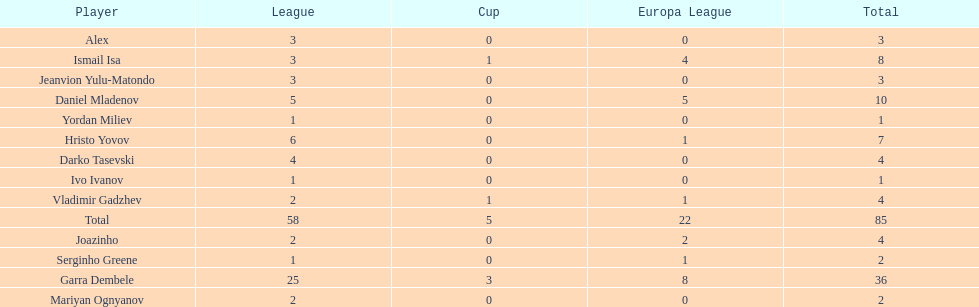Write the full table. {'header': ['Player', 'League', 'Cup', 'Europa League', 'Total'], 'rows': [['Alex', '3', '0', '0', '3'], ['Ismail Isa', '3', '1', '4', '8'], ['Jeanvion Yulu-Matondo', '3', '0', '0', '3'], ['Daniel Mladenov', '5', '0', '5', '10'], ['Yordan Miliev', '1', '0', '0', '1'], ['Hristo Yovov', '6', '0', '1', '7'], ['Darko Tasevski', '4', '0', '0', '4'], ['Ivo Ivanov', '1', '0', '0', '1'], ['Vladimir Gadzhev', '2', '1', '1', '4'], ['Total', '58', '5', '22', '85'], ['Joazinho', '2', '0', '2', '4'], ['Serginho Greene', '1', '0', '1', '2'], ['Garra Dembele', '25', '3', '8', '36'], ['Mariyan Ognyanov', '2', '0', '0', '2']]} Which players only scored one goal? Serginho Greene, Yordan Miliev, Ivo Ivanov. 